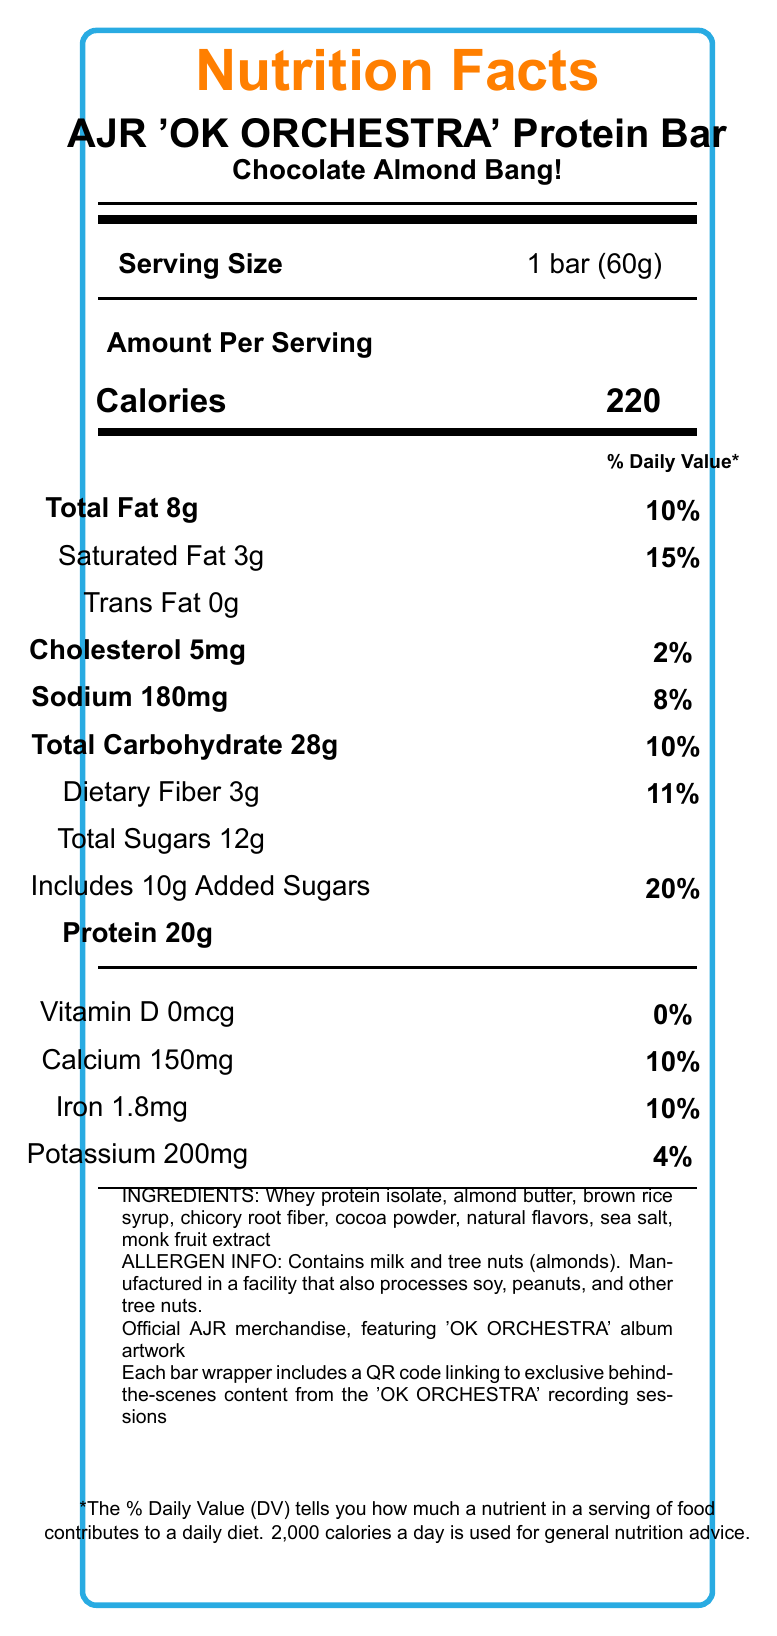who is the manufacturer of the AJR 'OK ORCHESTRA' Protein Bar? The document lists "Official AJR merchandise" under brand information, indicating that it is officially produced by AJR.
Answer: Official AJR merchandise what is the serving size of the AJR 'OK ORCHESTRA' Protein Bar? The serving size is displayed as "1 bar (60g)" under the "Serving Size" section.
Answer: 1 bar (60g) how many calories does one bar contain? The document clearly states "Calories" as 220 in the "Amount Per Serving" section.
Answer: 220 how much protein is in one bar? Under the "Amount Per Serving" section, the document specifies "Protein" as 20g.
Answer: 20g what are the allergens in the AJR 'OK ORCHESTRA' Protein Bar? The allergen information states that the bar contains milk and tree nuts (almonds).
Answer: Contains milk and tree nuts (almonds) which type of fat has the highest percentage of daily value in the AJR 'OK ORCHESTRA' Protein Bar? A. Total Fat B. Saturated Fat C. Trans Fat The document lists "Total Fat" at 10% and "Saturated Fat" at 15%, making "Saturated Fat" the highest.
Answer: B what is the percentage daily value of sodium in one bar? The "Sodium" section lists the daily value as 8%.
Answer: 8% which ingredient is not listed in the AJR 'OK ORCHESTRA' Protein Bar? A. Whey protein isolate B. Almond butter C. Soy lecithin The listed ingredients include whey protein isolate, almond butter, but not soy lecithin.
Answer: C does the AJR 'OK ORCHESTRA' Protein Bar contain any trans fat? The "Trans Fat" section lists the amount as "0g".
Answer: No how much added sugar is in one bar? The document clarifies that there are "Includes 10g Added Sugars" under the sugar information.
Answer: 10g describe what the AJR 'OK ORCHESTRA' Protein Bar is and what it contains. This summary includes all major information from the document, including nutritional facts, ingredients, allergen information, and branding details.
Answer: AJR 'OK ORCHESTRA' Protein Bar is an official AJR merchandise protein bar featuring 'OK ORCHESTRA' album artwork with a Chocolate Almond Bang! flavor. It contains 220 calories per serving, 8g total fat, 3g saturated fat, 5mg cholesterol, 180mg sodium, 28g total carbohydrates, 3g dietary fiber, 12g total sugars, 10g added sugars, and 20g protein. The ingredients include whey protein isolate, almond butter, brown rice syrup, chicory root fiber, cocoa powder, natural flavors, sea salt, and monk fruit extract. It contains milk and tree nuts (almonds). how much iron is in the AJR 'OK ORCHESTRA' Protein Bar? Under the vitamin and mineral information, the document states "Iron 1.8mg".
Answer: 1.8mg does the AJR 'OK ORCHESTRA' Protein Bar have any Vitamin D? The document lists "Vitamin D 0mcg" and a daily value of 0%.
Answer: No what kind of recording sessions can fans get exclusive content from by scanning the QR code? The document mentions that each bar wrapper includes a QR code linking to exclusive behind-the-scenes content from the 'OK ORCHESTRA' recording sessions.
Answer: 'OK ORCHESTRA' recording sessions does the AJR 'OK ORCHESTRA' Protein Bar cover the daily value of dietary fiber? The document lists "Dietary Fiber" at 11% of the daily value, indicating it does not cover 100% of the daily value for dietary fiber.
Answer: No what is the source of the natural flavors in the AJR 'OK ORCHESTRA' Protein Bar? The document lists "natural flavors" as an ingredient but does not specify the source of these flavors.
Answer: I don't know 